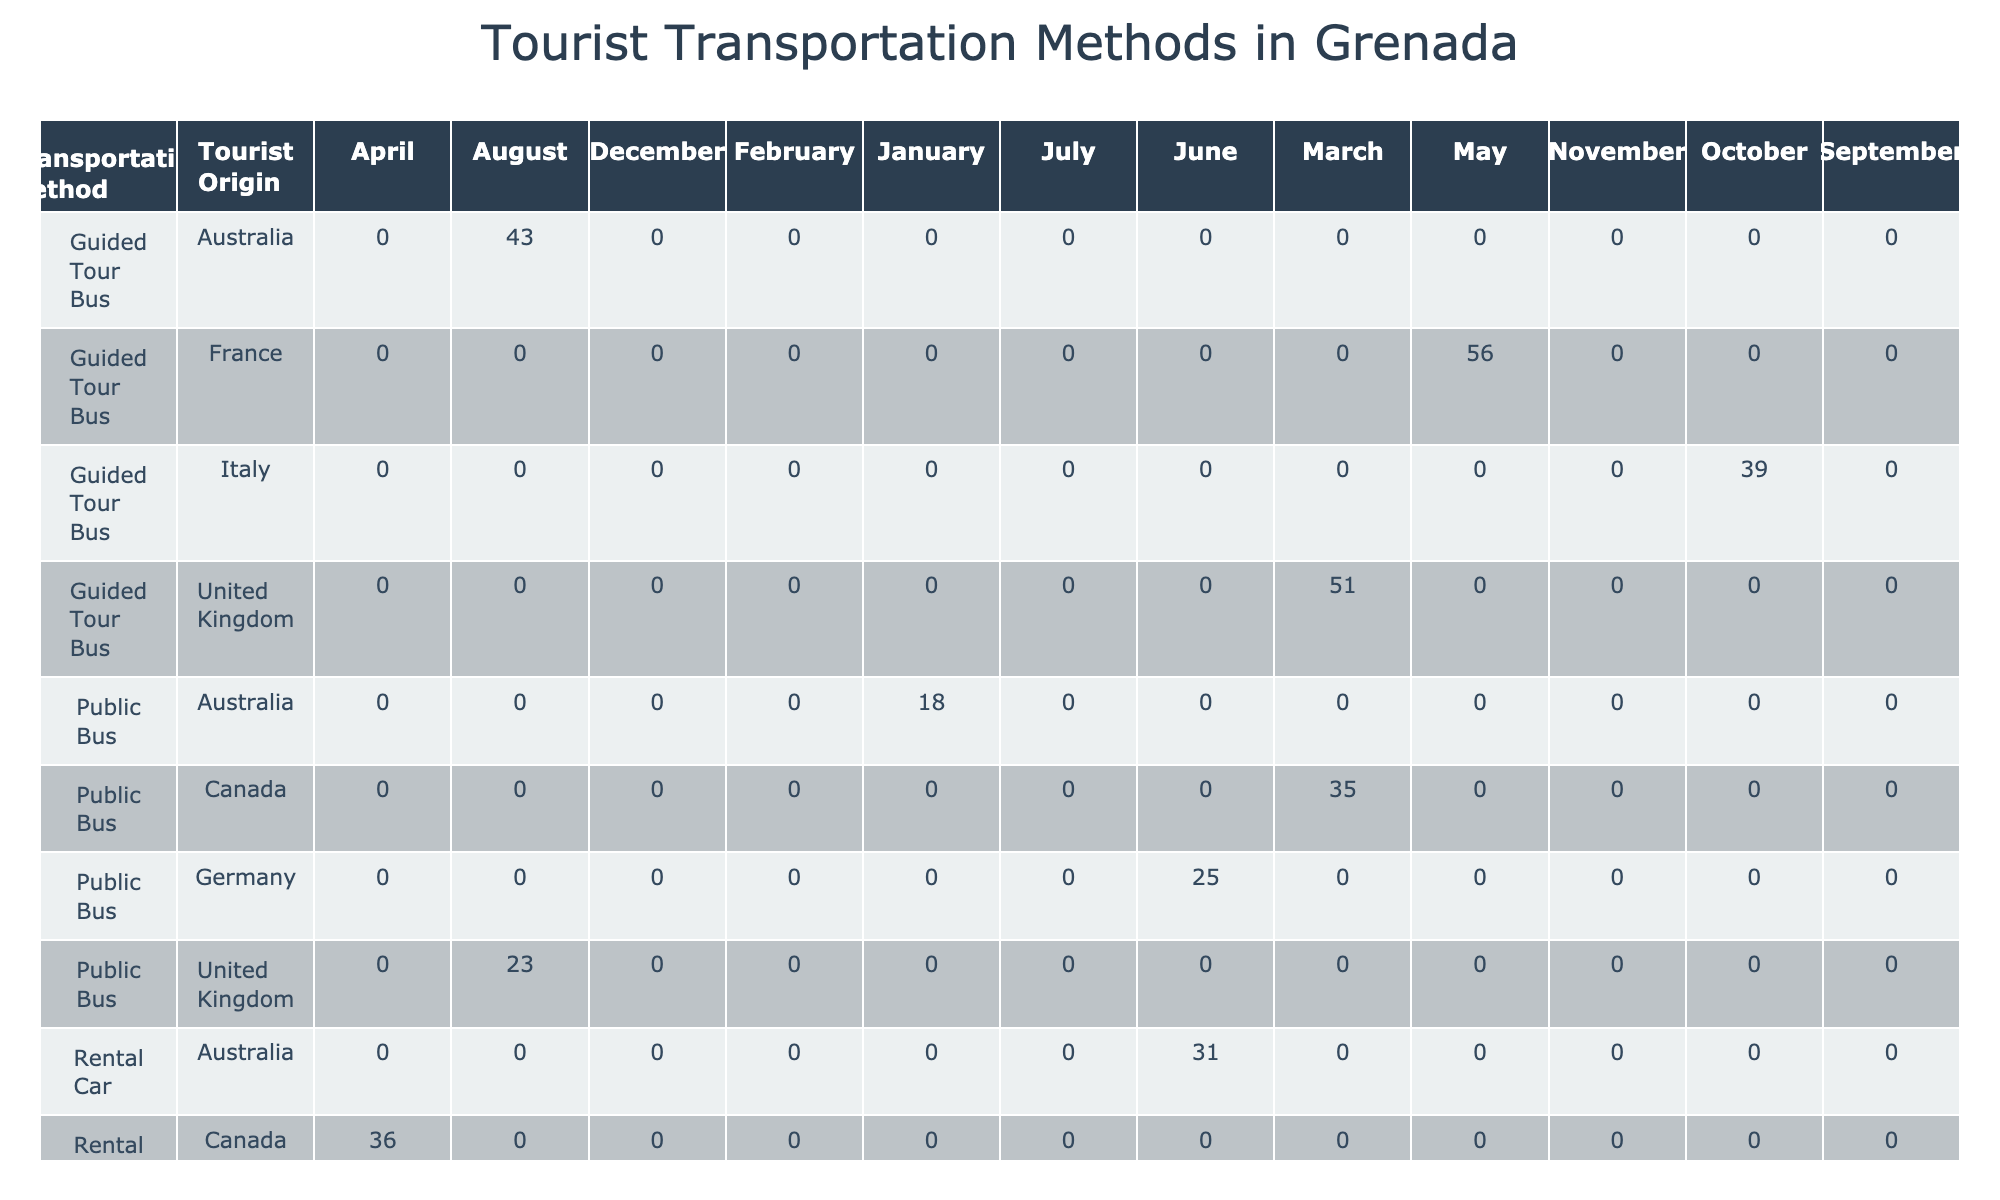What is the total number of tourists who used rental cars in January 2023? In the data, the rental car entries show that 42 tourists from the United States used this transportation method in January 2023. Therefore, the total number of tourists using rental cars in that month is 42.
Answer: 42 Which transportation method had the highest number of tourists in March 2024? By examining the March 2024 row, the guided tour bus from the United Kingdom had 51 tourists, which is more than any other mode of transportation in that month.
Answer: 51 Was the satisfaction rating for the water taxi from the United States higher than that of the public bus from the United Kingdom in July 2023? The satisfaction rating for the water taxi from the United States in July 2023 is 4.3, while the satisfaction rating for the public bus from the United Kingdom in August 2023 is 3.5. Since 4.3 is greater than 3.5, the statement is true.
Answer: Yes What is the average duration of stay for tourists using scooter rentals? To find the average duration, we need to sum the durations of each stay: 3 days + 2 days + 3 days + 2 days = 10 days. Then, divide this sum by the number of tourists using scooter rentals (4), so 10 days / 4 = 2.5 days is the average duration of stay for tourists using this method.
Answer: 2.5 days Which tourist origin had a satisfaction rating for guided tour buses that was above 4.5? The guided tour buses had the following satisfaction ratings: France 4.6 (May 2023), United Kingdom 4.8 (March 2024), and Australia 4.9 (August 2024). All of these origins had satisfaction ratings above 4.5 for guided tours.
Answer: France, United Kingdom, Australia How many tourists used public buses in total across all recorded months? The data displays values for public bus usage across 6 different months: March 2023 (35), August 2023 (23), January 2024 (18), June 2024 (25). Adding these numbers gives: 35 + 23 + 18 + 25 = 101 tourists used public buses in total across the recorded months.
Answer: 101 Was there any month where scooter rentals had more tourists than rental cars? By looking at the data, the only month where scooter rentals exceeded rental cars is February 2024 with scooter rentals totaling 22 tourists compared to 0 reported rental car tourists for that same month.
Answer: Yes What was the overall trend in tourist transportation use in Grenada from January 2023 to August 2024? To identify trends, one would have to analyze the changes in the number of tourists per transportation method month by month, either increasing or decreasing, as not directly observed in the data provided. From current values, we see fluctuations, but without an extensive analysis, the overall trend isn't clear-cut. However, there seems to be a mix of increases and decreases over various months instead of a consistent trend.
Answer: Mixed fluctuations 